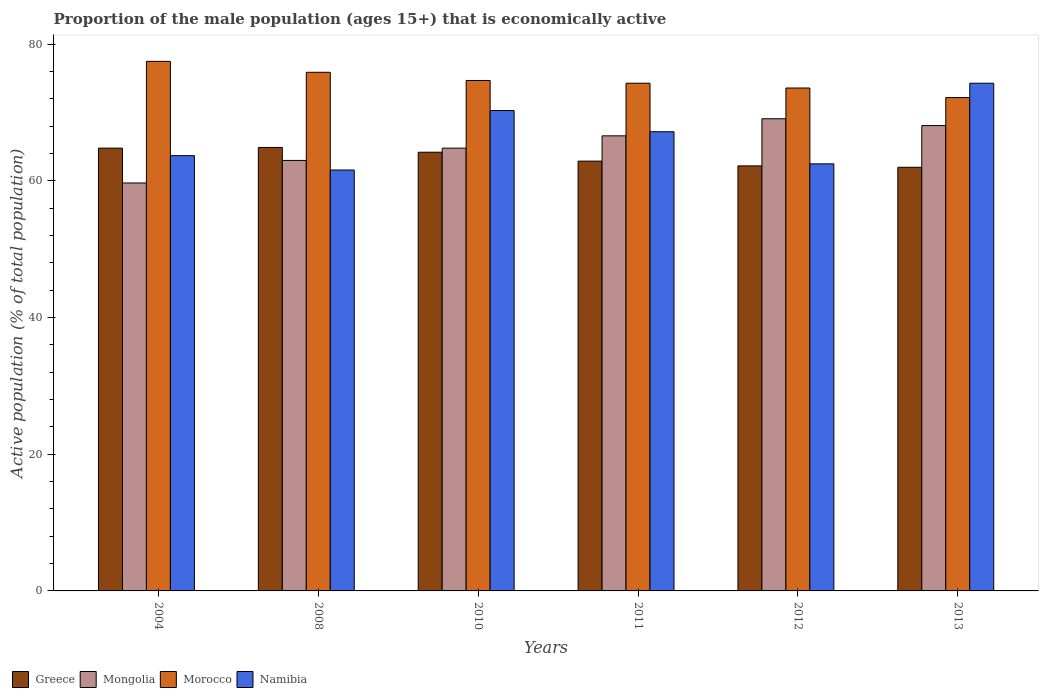How many different coloured bars are there?
Keep it short and to the point. 4. How many groups of bars are there?
Your answer should be compact. 6. Are the number of bars on each tick of the X-axis equal?
Provide a succinct answer. Yes. How many bars are there on the 6th tick from the right?
Your answer should be compact. 4. In how many cases, is the number of bars for a given year not equal to the number of legend labels?
Provide a succinct answer. 0. What is the proportion of the male population that is economically active in Greece in 2008?
Offer a terse response. 64.9. Across all years, what is the maximum proportion of the male population that is economically active in Greece?
Your answer should be compact. 64.9. Across all years, what is the minimum proportion of the male population that is economically active in Mongolia?
Provide a succinct answer. 59.7. What is the total proportion of the male population that is economically active in Morocco in the graph?
Offer a very short reply. 448.2. What is the difference between the proportion of the male population that is economically active in Mongolia in 2004 and that in 2013?
Ensure brevity in your answer.  -8.4. What is the difference between the proportion of the male population that is economically active in Morocco in 2008 and the proportion of the male population that is economically active in Mongolia in 2004?
Ensure brevity in your answer.  16.2. What is the average proportion of the male population that is economically active in Namibia per year?
Provide a succinct answer. 66.6. In the year 2004, what is the difference between the proportion of the male population that is economically active in Mongolia and proportion of the male population that is economically active in Greece?
Make the answer very short. -5.1. In how many years, is the proportion of the male population that is economically active in Morocco greater than 40 %?
Provide a short and direct response. 6. What is the ratio of the proportion of the male population that is economically active in Namibia in 2004 to that in 2013?
Provide a short and direct response. 0.86. Is the proportion of the male population that is economically active in Greece in 2008 less than that in 2011?
Make the answer very short. No. Is the difference between the proportion of the male population that is economically active in Mongolia in 2004 and 2011 greater than the difference between the proportion of the male population that is economically active in Greece in 2004 and 2011?
Your answer should be compact. No. What is the difference between the highest and the lowest proportion of the male population that is economically active in Morocco?
Provide a short and direct response. 5.3. Is it the case that in every year, the sum of the proportion of the male population that is economically active in Mongolia and proportion of the male population that is economically active in Greece is greater than the sum of proportion of the male population that is economically active in Namibia and proportion of the male population that is economically active in Morocco?
Offer a very short reply. No. What does the 1st bar from the right in 2013 represents?
Your answer should be very brief. Namibia. Is it the case that in every year, the sum of the proportion of the male population that is economically active in Greece and proportion of the male population that is economically active in Mongolia is greater than the proportion of the male population that is economically active in Namibia?
Your answer should be compact. Yes. Are all the bars in the graph horizontal?
Offer a very short reply. No. How many years are there in the graph?
Make the answer very short. 6. What is the difference between two consecutive major ticks on the Y-axis?
Make the answer very short. 20. Does the graph contain grids?
Make the answer very short. No. What is the title of the graph?
Your response must be concise. Proportion of the male population (ages 15+) that is economically active. Does "Other small states" appear as one of the legend labels in the graph?
Make the answer very short. No. What is the label or title of the Y-axis?
Provide a short and direct response. Active population (% of total population). What is the Active population (% of total population) in Greece in 2004?
Provide a short and direct response. 64.8. What is the Active population (% of total population) in Mongolia in 2004?
Ensure brevity in your answer.  59.7. What is the Active population (% of total population) in Morocco in 2004?
Give a very brief answer. 77.5. What is the Active population (% of total population) of Namibia in 2004?
Keep it short and to the point. 63.7. What is the Active population (% of total population) of Greece in 2008?
Offer a terse response. 64.9. What is the Active population (% of total population) of Morocco in 2008?
Your answer should be compact. 75.9. What is the Active population (% of total population) of Namibia in 2008?
Make the answer very short. 61.6. What is the Active population (% of total population) in Greece in 2010?
Offer a terse response. 64.2. What is the Active population (% of total population) of Mongolia in 2010?
Provide a succinct answer. 64.8. What is the Active population (% of total population) in Morocco in 2010?
Give a very brief answer. 74.7. What is the Active population (% of total population) in Namibia in 2010?
Provide a succinct answer. 70.3. What is the Active population (% of total population) in Greece in 2011?
Provide a short and direct response. 62.9. What is the Active population (% of total population) of Mongolia in 2011?
Keep it short and to the point. 66.6. What is the Active population (% of total population) in Morocco in 2011?
Give a very brief answer. 74.3. What is the Active population (% of total population) in Namibia in 2011?
Make the answer very short. 67.2. What is the Active population (% of total population) in Greece in 2012?
Give a very brief answer. 62.2. What is the Active population (% of total population) in Mongolia in 2012?
Make the answer very short. 69.1. What is the Active population (% of total population) of Morocco in 2012?
Ensure brevity in your answer.  73.6. What is the Active population (% of total population) of Namibia in 2012?
Offer a terse response. 62.5. What is the Active population (% of total population) of Greece in 2013?
Make the answer very short. 62. What is the Active population (% of total population) in Mongolia in 2013?
Offer a terse response. 68.1. What is the Active population (% of total population) in Morocco in 2013?
Your answer should be very brief. 72.2. What is the Active population (% of total population) in Namibia in 2013?
Offer a very short reply. 74.3. Across all years, what is the maximum Active population (% of total population) in Greece?
Your response must be concise. 64.9. Across all years, what is the maximum Active population (% of total population) in Mongolia?
Offer a very short reply. 69.1. Across all years, what is the maximum Active population (% of total population) of Morocco?
Offer a very short reply. 77.5. Across all years, what is the maximum Active population (% of total population) of Namibia?
Ensure brevity in your answer.  74.3. Across all years, what is the minimum Active population (% of total population) of Mongolia?
Offer a terse response. 59.7. Across all years, what is the minimum Active population (% of total population) in Morocco?
Your answer should be very brief. 72.2. Across all years, what is the minimum Active population (% of total population) in Namibia?
Keep it short and to the point. 61.6. What is the total Active population (% of total population) in Greece in the graph?
Your answer should be very brief. 381. What is the total Active population (% of total population) of Mongolia in the graph?
Provide a succinct answer. 391.3. What is the total Active population (% of total population) of Morocco in the graph?
Offer a very short reply. 448.2. What is the total Active population (% of total population) of Namibia in the graph?
Offer a terse response. 399.6. What is the difference between the Active population (% of total population) of Greece in 2004 and that in 2008?
Your response must be concise. -0.1. What is the difference between the Active population (% of total population) in Mongolia in 2004 and that in 2008?
Give a very brief answer. -3.3. What is the difference between the Active population (% of total population) in Morocco in 2004 and that in 2008?
Provide a succinct answer. 1.6. What is the difference between the Active population (% of total population) of Greece in 2004 and that in 2010?
Keep it short and to the point. 0.6. What is the difference between the Active population (% of total population) in Morocco in 2004 and that in 2010?
Ensure brevity in your answer.  2.8. What is the difference between the Active population (% of total population) of Greece in 2004 and that in 2011?
Your response must be concise. 1.9. What is the difference between the Active population (% of total population) in Mongolia in 2004 and that in 2011?
Your answer should be compact. -6.9. What is the difference between the Active population (% of total population) in Namibia in 2004 and that in 2011?
Ensure brevity in your answer.  -3.5. What is the difference between the Active population (% of total population) in Morocco in 2004 and that in 2012?
Offer a terse response. 3.9. What is the difference between the Active population (% of total population) in Greece in 2004 and that in 2013?
Make the answer very short. 2.8. What is the difference between the Active population (% of total population) of Morocco in 2004 and that in 2013?
Keep it short and to the point. 5.3. What is the difference between the Active population (% of total population) in Namibia in 2008 and that in 2010?
Your response must be concise. -8.7. What is the difference between the Active population (% of total population) in Mongolia in 2008 and that in 2011?
Your answer should be very brief. -3.6. What is the difference between the Active population (% of total population) of Mongolia in 2008 and that in 2012?
Keep it short and to the point. -6.1. What is the difference between the Active population (% of total population) of Namibia in 2008 and that in 2012?
Your answer should be very brief. -0.9. What is the difference between the Active population (% of total population) of Mongolia in 2008 and that in 2013?
Provide a succinct answer. -5.1. What is the difference between the Active population (% of total population) of Morocco in 2008 and that in 2013?
Offer a very short reply. 3.7. What is the difference between the Active population (% of total population) of Namibia in 2008 and that in 2013?
Your answer should be compact. -12.7. What is the difference between the Active population (% of total population) of Mongolia in 2010 and that in 2011?
Provide a short and direct response. -1.8. What is the difference between the Active population (% of total population) of Morocco in 2010 and that in 2011?
Offer a very short reply. 0.4. What is the difference between the Active population (% of total population) of Namibia in 2010 and that in 2012?
Ensure brevity in your answer.  7.8. What is the difference between the Active population (% of total population) in Mongolia in 2010 and that in 2013?
Offer a very short reply. -3.3. What is the difference between the Active population (% of total population) in Greece in 2011 and that in 2012?
Offer a terse response. 0.7. What is the difference between the Active population (% of total population) in Mongolia in 2011 and that in 2012?
Your answer should be very brief. -2.5. What is the difference between the Active population (% of total population) in Morocco in 2011 and that in 2012?
Offer a very short reply. 0.7. What is the difference between the Active population (% of total population) in Namibia in 2011 and that in 2012?
Keep it short and to the point. 4.7. What is the difference between the Active population (% of total population) of Mongolia in 2011 and that in 2013?
Make the answer very short. -1.5. What is the difference between the Active population (% of total population) of Morocco in 2011 and that in 2013?
Give a very brief answer. 2.1. What is the difference between the Active population (% of total population) in Namibia in 2011 and that in 2013?
Your answer should be compact. -7.1. What is the difference between the Active population (% of total population) of Greece in 2012 and that in 2013?
Give a very brief answer. 0.2. What is the difference between the Active population (% of total population) of Mongolia in 2004 and the Active population (% of total population) of Morocco in 2008?
Provide a succinct answer. -16.2. What is the difference between the Active population (% of total population) of Mongolia in 2004 and the Active population (% of total population) of Namibia in 2008?
Make the answer very short. -1.9. What is the difference between the Active population (% of total population) of Morocco in 2004 and the Active population (% of total population) of Namibia in 2008?
Provide a short and direct response. 15.9. What is the difference between the Active population (% of total population) of Greece in 2004 and the Active population (% of total population) of Morocco in 2010?
Give a very brief answer. -9.9. What is the difference between the Active population (% of total population) in Greece in 2004 and the Active population (% of total population) in Namibia in 2010?
Provide a short and direct response. -5.5. What is the difference between the Active population (% of total population) in Greece in 2004 and the Active population (% of total population) in Mongolia in 2011?
Provide a succinct answer. -1.8. What is the difference between the Active population (% of total population) in Mongolia in 2004 and the Active population (% of total population) in Morocco in 2011?
Keep it short and to the point. -14.6. What is the difference between the Active population (% of total population) of Mongolia in 2004 and the Active population (% of total population) of Namibia in 2011?
Give a very brief answer. -7.5. What is the difference between the Active population (% of total population) of Greece in 2004 and the Active population (% of total population) of Mongolia in 2012?
Keep it short and to the point. -4.3. What is the difference between the Active population (% of total population) in Greece in 2004 and the Active population (% of total population) in Morocco in 2012?
Your answer should be very brief. -8.8. What is the difference between the Active population (% of total population) of Morocco in 2004 and the Active population (% of total population) of Namibia in 2012?
Your answer should be compact. 15. What is the difference between the Active population (% of total population) in Greece in 2004 and the Active population (% of total population) in Namibia in 2013?
Keep it short and to the point. -9.5. What is the difference between the Active population (% of total population) in Mongolia in 2004 and the Active population (% of total population) in Namibia in 2013?
Your answer should be very brief. -14.6. What is the difference between the Active population (% of total population) of Morocco in 2004 and the Active population (% of total population) of Namibia in 2013?
Your answer should be very brief. 3.2. What is the difference between the Active population (% of total population) of Greece in 2008 and the Active population (% of total population) of Namibia in 2010?
Offer a very short reply. -5.4. What is the difference between the Active population (% of total population) in Morocco in 2008 and the Active population (% of total population) in Namibia in 2010?
Give a very brief answer. 5.6. What is the difference between the Active population (% of total population) in Greece in 2008 and the Active population (% of total population) in Mongolia in 2011?
Give a very brief answer. -1.7. What is the difference between the Active population (% of total population) in Greece in 2008 and the Active population (% of total population) in Morocco in 2011?
Give a very brief answer. -9.4. What is the difference between the Active population (% of total population) of Mongolia in 2008 and the Active population (% of total population) of Morocco in 2011?
Make the answer very short. -11.3. What is the difference between the Active population (% of total population) in Mongolia in 2008 and the Active population (% of total population) in Namibia in 2011?
Ensure brevity in your answer.  -4.2. What is the difference between the Active population (% of total population) of Morocco in 2008 and the Active population (% of total population) of Namibia in 2011?
Offer a terse response. 8.7. What is the difference between the Active population (% of total population) in Greece in 2008 and the Active population (% of total population) in Mongolia in 2012?
Offer a terse response. -4.2. What is the difference between the Active population (% of total population) of Greece in 2008 and the Active population (% of total population) of Morocco in 2012?
Give a very brief answer. -8.7. What is the difference between the Active population (% of total population) of Greece in 2008 and the Active population (% of total population) of Namibia in 2012?
Make the answer very short. 2.4. What is the difference between the Active population (% of total population) in Mongolia in 2008 and the Active population (% of total population) in Namibia in 2012?
Provide a succinct answer. 0.5. What is the difference between the Active population (% of total population) in Greece in 2008 and the Active population (% of total population) in Mongolia in 2013?
Give a very brief answer. -3.2. What is the difference between the Active population (% of total population) of Greece in 2008 and the Active population (% of total population) of Morocco in 2013?
Provide a short and direct response. -7.3. What is the difference between the Active population (% of total population) of Greece in 2008 and the Active population (% of total population) of Namibia in 2013?
Your answer should be very brief. -9.4. What is the difference between the Active population (% of total population) in Greece in 2010 and the Active population (% of total population) in Morocco in 2011?
Make the answer very short. -10.1. What is the difference between the Active population (% of total population) of Greece in 2010 and the Active population (% of total population) of Namibia in 2011?
Your answer should be very brief. -3. What is the difference between the Active population (% of total population) of Mongolia in 2010 and the Active population (% of total population) of Morocco in 2011?
Your answer should be compact. -9.5. What is the difference between the Active population (% of total population) of Greece in 2010 and the Active population (% of total population) of Morocco in 2012?
Offer a terse response. -9.4. What is the difference between the Active population (% of total population) in Greece in 2010 and the Active population (% of total population) in Namibia in 2012?
Provide a short and direct response. 1.7. What is the difference between the Active population (% of total population) of Greece in 2010 and the Active population (% of total population) of Morocco in 2013?
Your answer should be compact. -8. What is the difference between the Active population (% of total population) of Morocco in 2010 and the Active population (% of total population) of Namibia in 2013?
Provide a succinct answer. 0.4. What is the difference between the Active population (% of total population) in Greece in 2011 and the Active population (% of total population) in Morocco in 2012?
Make the answer very short. -10.7. What is the difference between the Active population (% of total population) in Mongolia in 2011 and the Active population (% of total population) in Morocco in 2012?
Provide a succinct answer. -7. What is the difference between the Active population (% of total population) of Mongolia in 2011 and the Active population (% of total population) of Namibia in 2012?
Give a very brief answer. 4.1. What is the difference between the Active population (% of total population) of Morocco in 2011 and the Active population (% of total population) of Namibia in 2012?
Keep it short and to the point. 11.8. What is the difference between the Active population (% of total population) in Greece in 2011 and the Active population (% of total population) in Mongolia in 2013?
Offer a terse response. -5.2. What is the difference between the Active population (% of total population) in Mongolia in 2011 and the Active population (% of total population) in Morocco in 2013?
Your answer should be very brief. -5.6. What is the difference between the Active population (% of total population) of Morocco in 2011 and the Active population (% of total population) of Namibia in 2013?
Ensure brevity in your answer.  0. What is the difference between the Active population (% of total population) in Greece in 2012 and the Active population (% of total population) in Mongolia in 2013?
Your answer should be very brief. -5.9. What is the difference between the Active population (% of total population) of Greece in 2012 and the Active population (% of total population) of Morocco in 2013?
Provide a succinct answer. -10. What is the difference between the Active population (% of total population) in Greece in 2012 and the Active population (% of total population) in Namibia in 2013?
Make the answer very short. -12.1. What is the difference between the Active population (% of total population) of Mongolia in 2012 and the Active population (% of total population) of Namibia in 2013?
Ensure brevity in your answer.  -5.2. What is the average Active population (% of total population) of Greece per year?
Provide a short and direct response. 63.5. What is the average Active population (% of total population) in Mongolia per year?
Your answer should be very brief. 65.22. What is the average Active population (% of total population) in Morocco per year?
Your answer should be compact. 74.7. What is the average Active population (% of total population) in Namibia per year?
Make the answer very short. 66.6. In the year 2004, what is the difference between the Active population (% of total population) in Greece and Active population (% of total population) in Morocco?
Your answer should be very brief. -12.7. In the year 2004, what is the difference between the Active population (% of total population) in Mongolia and Active population (% of total population) in Morocco?
Make the answer very short. -17.8. In the year 2004, what is the difference between the Active population (% of total population) of Mongolia and Active population (% of total population) of Namibia?
Make the answer very short. -4. In the year 2004, what is the difference between the Active population (% of total population) in Morocco and Active population (% of total population) in Namibia?
Your response must be concise. 13.8. In the year 2008, what is the difference between the Active population (% of total population) of Greece and Active population (% of total population) of Morocco?
Ensure brevity in your answer.  -11. In the year 2008, what is the difference between the Active population (% of total population) in Greece and Active population (% of total population) in Namibia?
Ensure brevity in your answer.  3.3. In the year 2008, what is the difference between the Active population (% of total population) in Mongolia and Active population (% of total population) in Morocco?
Give a very brief answer. -12.9. In the year 2008, what is the difference between the Active population (% of total population) of Mongolia and Active population (% of total population) of Namibia?
Provide a succinct answer. 1.4. In the year 2010, what is the difference between the Active population (% of total population) of Greece and Active population (% of total population) of Mongolia?
Ensure brevity in your answer.  -0.6. In the year 2010, what is the difference between the Active population (% of total population) of Greece and Active population (% of total population) of Namibia?
Offer a terse response. -6.1. In the year 2010, what is the difference between the Active population (% of total population) of Mongolia and Active population (% of total population) of Morocco?
Provide a short and direct response. -9.9. In the year 2010, what is the difference between the Active population (% of total population) in Mongolia and Active population (% of total population) in Namibia?
Your response must be concise. -5.5. In the year 2010, what is the difference between the Active population (% of total population) in Morocco and Active population (% of total population) in Namibia?
Your response must be concise. 4.4. In the year 2011, what is the difference between the Active population (% of total population) in Greece and Active population (% of total population) in Namibia?
Provide a succinct answer. -4.3. In the year 2011, what is the difference between the Active population (% of total population) of Mongolia and Active population (% of total population) of Morocco?
Make the answer very short. -7.7. In the year 2012, what is the difference between the Active population (% of total population) of Mongolia and Active population (% of total population) of Morocco?
Provide a short and direct response. -4.5. In the year 2012, what is the difference between the Active population (% of total population) in Morocco and Active population (% of total population) in Namibia?
Give a very brief answer. 11.1. In the year 2013, what is the difference between the Active population (% of total population) in Mongolia and Active population (% of total population) in Morocco?
Your response must be concise. -4.1. In the year 2013, what is the difference between the Active population (% of total population) in Mongolia and Active population (% of total population) in Namibia?
Keep it short and to the point. -6.2. What is the ratio of the Active population (% of total population) in Mongolia in 2004 to that in 2008?
Ensure brevity in your answer.  0.95. What is the ratio of the Active population (% of total population) of Morocco in 2004 to that in 2008?
Keep it short and to the point. 1.02. What is the ratio of the Active population (% of total population) of Namibia in 2004 to that in 2008?
Your answer should be compact. 1.03. What is the ratio of the Active population (% of total population) in Greece in 2004 to that in 2010?
Offer a very short reply. 1.01. What is the ratio of the Active population (% of total population) in Mongolia in 2004 to that in 2010?
Make the answer very short. 0.92. What is the ratio of the Active population (% of total population) in Morocco in 2004 to that in 2010?
Ensure brevity in your answer.  1.04. What is the ratio of the Active population (% of total population) in Namibia in 2004 to that in 2010?
Offer a very short reply. 0.91. What is the ratio of the Active population (% of total population) in Greece in 2004 to that in 2011?
Offer a very short reply. 1.03. What is the ratio of the Active population (% of total population) of Mongolia in 2004 to that in 2011?
Keep it short and to the point. 0.9. What is the ratio of the Active population (% of total population) of Morocco in 2004 to that in 2011?
Your response must be concise. 1.04. What is the ratio of the Active population (% of total population) of Namibia in 2004 to that in 2011?
Provide a short and direct response. 0.95. What is the ratio of the Active population (% of total population) of Greece in 2004 to that in 2012?
Keep it short and to the point. 1.04. What is the ratio of the Active population (% of total population) of Mongolia in 2004 to that in 2012?
Your answer should be compact. 0.86. What is the ratio of the Active population (% of total population) in Morocco in 2004 to that in 2012?
Offer a terse response. 1.05. What is the ratio of the Active population (% of total population) in Namibia in 2004 to that in 2012?
Make the answer very short. 1.02. What is the ratio of the Active population (% of total population) in Greece in 2004 to that in 2013?
Your response must be concise. 1.05. What is the ratio of the Active population (% of total population) in Mongolia in 2004 to that in 2013?
Give a very brief answer. 0.88. What is the ratio of the Active population (% of total population) of Morocco in 2004 to that in 2013?
Keep it short and to the point. 1.07. What is the ratio of the Active population (% of total population) of Namibia in 2004 to that in 2013?
Keep it short and to the point. 0.86. What is the ratio of the Active population (% of total population) of Greece in 2008 to that in 2010?
Make the answer very short. 1.01. What is the ratio of the Active population (% of total population) in Mongolia in 2008 to that in 2010?
Offer a very short reply. 0.97. What is the ratio of the Active population (% of total population) of Morocco in 2008 to that in 2010?
Make the answer very short. 1.02. What is the ratio of the Active population (% of total population) in Namibia in 2008 to that in 2010?
Offer a terse response. 0.88. What is the ratio of the Active population (% of total population) in Greece in 2008 to that in 2011?
Give a very brief answer. 1.03. What is the ratio of the Active population (% of total population) in Mongolia in 2008 to that in 2011?
Offer a terse response. 0.95. What is the ratio of the Active population (% of total population) of Morocco in 2008 to that in 2011?
Provide a succinct answer. 1.02. What is the ratio of the Active population (% of total population) in Greece in 2008 to that in 2012?
Give a very brief answer. 1.04. What is the ratio of the Active population (% of total population) in Mongolia in 2008 to that in 2012?
Provide a succinct answer. 0.91. What is the ratio of the Active population (% of total population) of Morocco in 2008 to that in 2012?
Provide a succinct answer. 1.03. What is the ratio of the Active population (% of total population) of Namibia in 2008 to that in 2012?
Make the answer very short. 0.99. What is the ratio of the Active population (% of total population) of Greece in 2008 to that in 2013?
Give a very brief answer. 1.05. What is the ratio of the Active population (% of total population) in Mongolia in 2008 to that in 2013?
Make the answer very short. 0.93. What is the ratio of the Active population (% of total population) in Morocco in 2008 to that in 2013?
Your response must be concise. 1.05. What is the ratio of the Active population (% of total population) in Namibia in 2008 to that in 2013?
Your response must be concise. 0.83. What is the ratio of the Active population (% of total population) of Greece in 2010 to that in 2011?
Your response must be concise. 1.02. What is the ratio of the Active population (% of total population) of Mongolia in 2010 to that in 2011?
Your answer should be compact. 0.97. What is the ratio of the Active population (% of total population) of Morocco in 2010 to that in 2011?
Give a very brief answer. 1.01. What is the ratio of the Active population (% of total population) in Namibia in 2010 to that in 2011?
Your answer should be very brief. 1.05. What is the ratio of the Active population (% of total population) in Greece in 2010 to that in 2012?
Offer a very short reply. 1.03. What is the ratio of the Active population (% of total population) in Mongolia in 2010 to that in 2012?
Your response must be concise. 0.94. What is the ratio of the Active population (% of total population) of Morocco in 2010 to that in 2012?
Offer a very short reply. 1.01. What is the ratio of the Active population (% of total population) in Namibia in 2010 to that in 2012?
Provide a short and direct response. 1.12. What is the ratio of the Active population (% of total population) in Greece in 2010 to that in 2013?
Give a very brief answer. 1.04. What is the ratio of the Active population (% of total population) of Mongolia in 2010 to that in 2013?
Your response must be concise. 0.95. What is the ratio of the Active population (% of total population) of Morocco in 2010 to that in 2013?
Make the answer very short. 1.03. What is the ratio of the Active population (% of total population) in Namibia in 2010 to that in 2013?
Offer a terse response. 0.95. What is the ratio of the Active population (% of total population) in Greece in 2011 to that in 2012?
Ensure brevity in your answer.  1.01. What is the ratio of the Active population (% of total population) in Mongolia in 2011 to that in 2012?
Your answer should be compact. 0.96. What is the ratio of the Active population (% of total population) in Morocco in 2011 to that in 2012?
Provide a succinct answer. 1.01. What is the ratio of the Active population (% of total population) of Namibia in 2011 to that in 2012?
Offer a very short reply. 1.08. What is the ratio of the Active population (% of total population) in Greece in 2011 to that in 2013?
Ensure brevity in your answer.  1.01. What is the ratio of the Active population (% of total population) in Morocco in 2011 to that in 2013?
Offer a terse response. 1.03. What is the ratio of the Active population (% of total population) in Namibia in 2011 to that in 2013?
Offer a terse response. 0.9. What is the ratio of the Active population (% of total population) in Mongolia in 2012 to that in 2013?
Provide a short and direct response. 1.01. What is the ratio of the Active population (% of total population) of Morocco in 2012 to that in 2013?
Your answer should be very brief. 1.02. What is the ratio of the Active population (% of total population) of Namibia in 2012 to that in 2013?
Keep it short and to the point. 0.84. What is the difference between the highest and the second highest Active population (% of total population) in Greece?
Your response must be concise. 0.1. What is the difference between the highest and the second highest Active population (% of total population) in Mongolia?
Your answer should be compact. 1. What is the difference between the highest and the second highest Active population (% of total population) of Morocco?
Make the answer very short. 1.6. What is the difference between the highest and the lowest Active population (% of total population) in Mongolia?
Ensure brevity in your answer.  9.4. What is the difference between the highest and the lowest Active population (% of total population) in Morocco?
Your response must be concise. 5.3. 